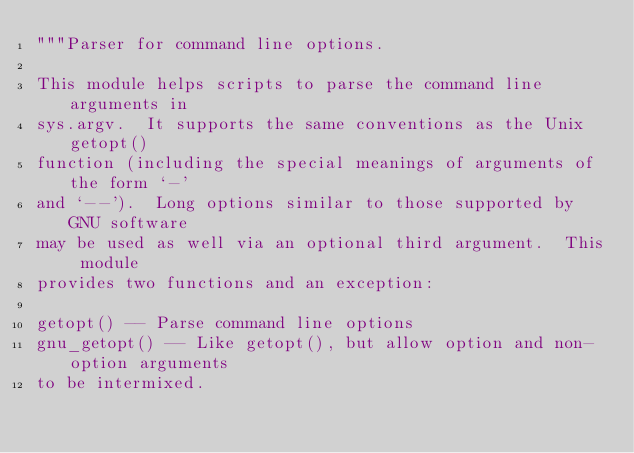<code> <loc_0><loc_0><loc_500><loc_500><_Python_>"""Parser for command line options.

This module helps scripts to parse the command line arguments in
sys.argv.  It supports the same conventions as the Unix getopt()
function (including the special meanings of arguments of the form `-'
and `--').  Long options similar to those supported by GNU software
may be used as well via an optional third argument.  This module
provides two functions and an exception:

getopt() -- Parse command line options
gnu_getopt() -- Like getopt(), but allow option and non-option arguments
to be intermixed.</code> 